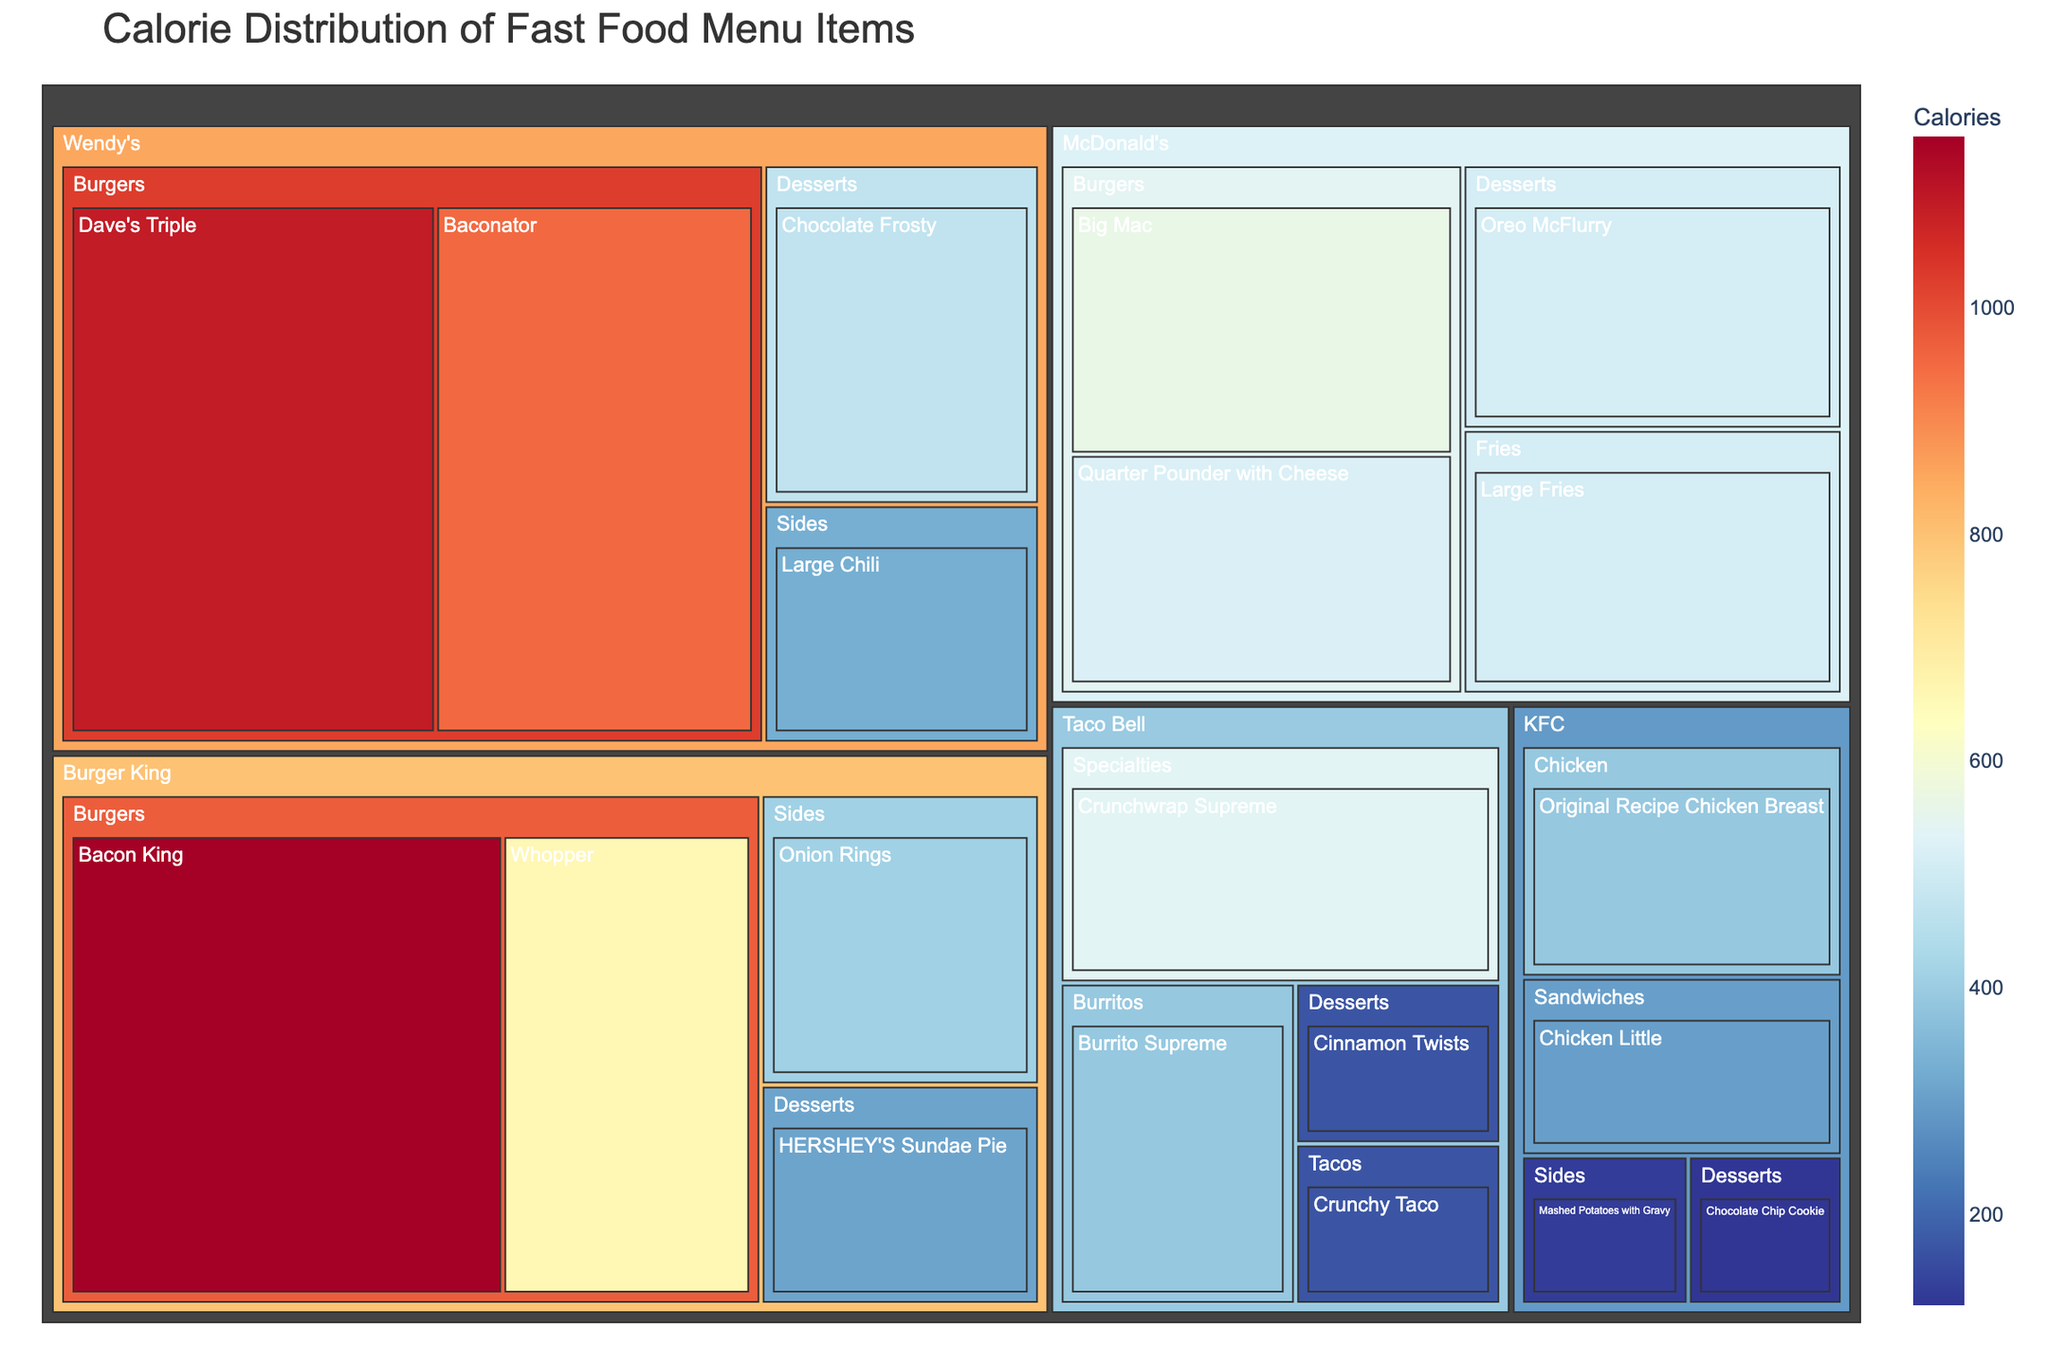What's the highest calorie item from Burger King? By inspecting the treemap, we can see that the "Bacon King" from Burger King has the largest area and the darkest color, indicating it has the highest calorie content among Burger King items.
Answer: Bacon King Which restaurant has the lowest calorie item on the list? By analyzing the treemap, we see that KFC's "Chocolate Chip Cookie" has the smallest and lightest-colored box within KFC, signifying it has the fewest calories.
Answer: KFC How many categories of items does McDonald's have in the plot? By exploring the treemap, we see McDonald's has four categories: Burgers, Fries, Desserts, and another unspecified category indicated by different colored sections.
Answer: Four What's the total number of calories for all dessert items across all restaurants? By adding the calorie content of all dessert items regardless of the restaurant: Oreo McFlurry (510), HERSHEY'S Sundae Pie (310), Chocolate Frosty (470), Cinnamon Twists (170), and Chocolate Chip Cookie (120), we get a total of 510 + 310 + 470 + 170 + 120 = 1580 calories.
Answer: 1580 Which restaurant has more high-calorie burgers, Wendy's or McDonald's? By comparing the burger items from Wendy's and McDonald's, we see that Wendy's has higher-calorie burgers (Dave's Triple: 1090, Baconator: 950) compared to McDonald's (Big Mac: 563, Quarter Pounder with Cheese: 520).
Answer: Wendy's Compare the total calories of Taco Bell’s Burritos and Sides categories. Which one is higher? Taco Bell's Burritos have a summed calorie content of 390, while the Sides' calorie content is comparable but lower. By checking the treemap portions, we confirm the higher calorie count for Burritos over Sides for Taco Bell.
Answer: Burritos What is the most calorie-dense item at McDonald's? By viewing the treemap, the darkest-shaded box within the McDonald's section represents the calorie-dense "Big Mac" and "Quarter Pounder with Cheese" (both less than the larger areas of other chains).
Answer: Big Mac Is there any item with fewer than 200 calories in the plot? By inspecting the treemap, we see that Taco Bell's "Crunchy Taco" and "Cinnamon Twists" both have sections that are lighter and smaller, indicating their caloric content is below 200 calories.
Answer: Yes How does the caloric content of KFC’s Original Recipe Chicken Breast compare to Taco Bell’s Burrito Supreme? Observing the treemap, KFC’s Original Recipe Chicken Breast (390 calories) is nearly equivalent to Taco Bell’s Burrito Supreme (390 calories), with barely distinguishable size/color.
Answer: Equal Which category has more items, burgers or desserts? By counting sections, we see the treemap indicates more unique burger items across different restaurants compared to dessert items.
Answer: Burgers 